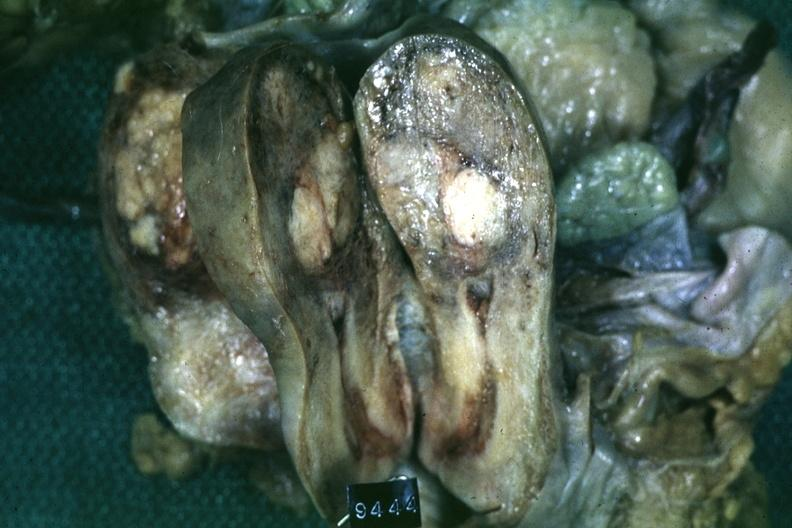s uterus present?
Answer the question using a single word or phrase. Yes 